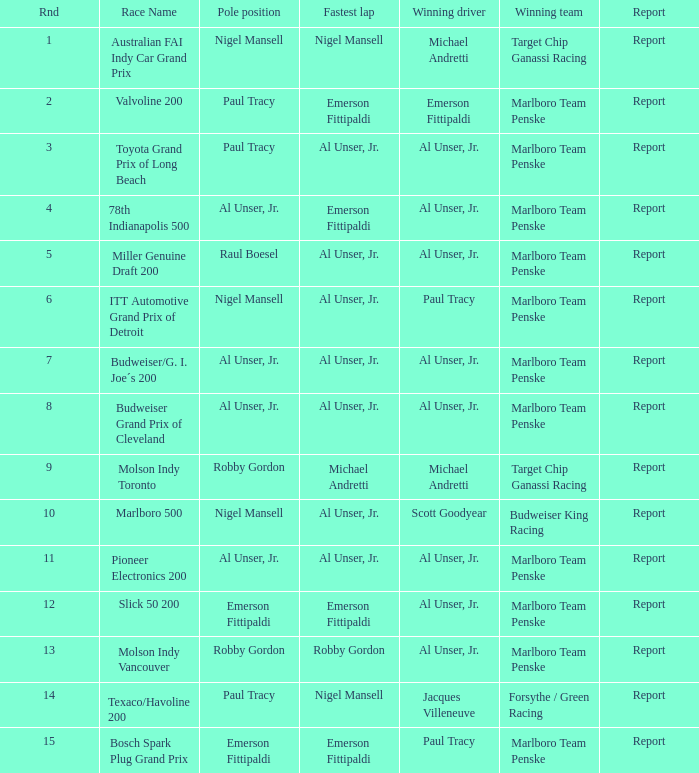What's the report of the race won by Michael Andretti, with Nigel Mansell driving the fastest lap? Report. 